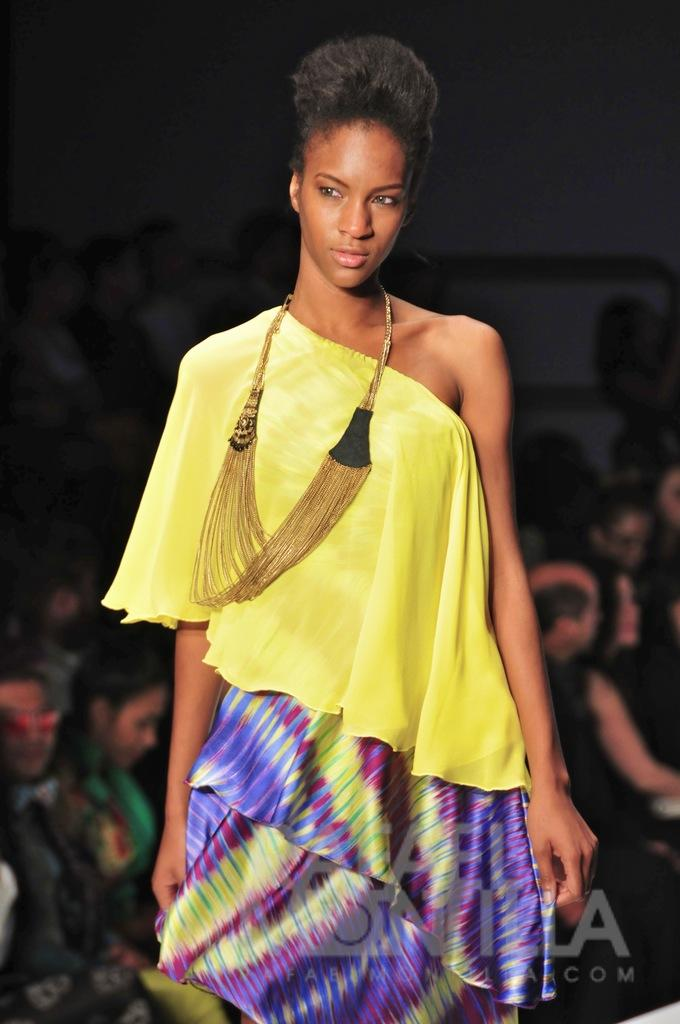Who are the main subjects in the image? There are women in the center of the image. What can be seen in the background of the image? There is a crowd in the background of the image. What type of mist can be seen surrounding the women in the image? There is no mist present in the image; it features women in the center and a crowd in the background. 